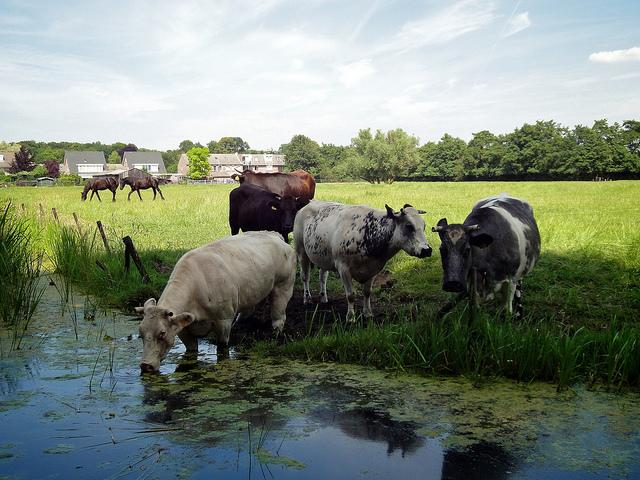Why does the animal have its head to the water? Please explain your reasoning. to drink. There is water and the animal's head is near it. 